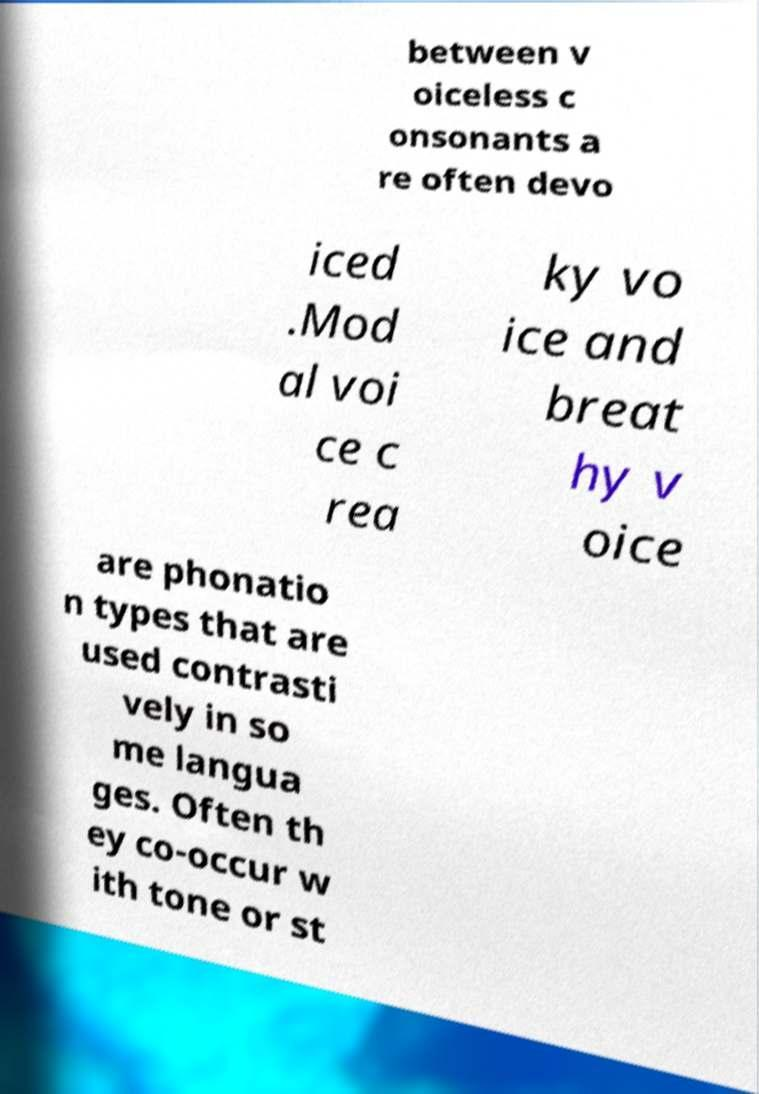Could you assist in decoding the text presented in this image and type it out clearly? between v oiceless c onsonants a re often devo iced .Mod al voi ce c rea ky vo ice and breat hy v oice are phonatio n types that are used contrasti vely in so me langua ges. Often th ey co-occur w ith tone or st 